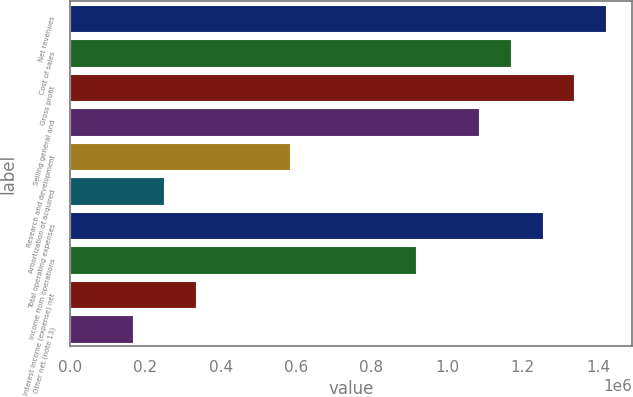Convert chart. <chart><loc_0><loc_0><loc_500><loc_500><bar_chart><fcel>Net revenues<fcel>Cost of sales<fcel>Gross profit<fcel>Selling general and<fcel>Research and development<fcel>Amortization of acquired<fcel>Total operating expenses<fcel>Income from operations<fcel>Interest income (expense) net<fcel>Other net (note 13)<nl><fcel>1.42017e+06<fcel>1.16956e+06<fcel>1.33663e+06<fcel>1.08602e+06<fcel>584778<fcel>250620<fcel>1.25309e+06<fcel>918937<fcel>334160<fcel>167081<nl></chart> 